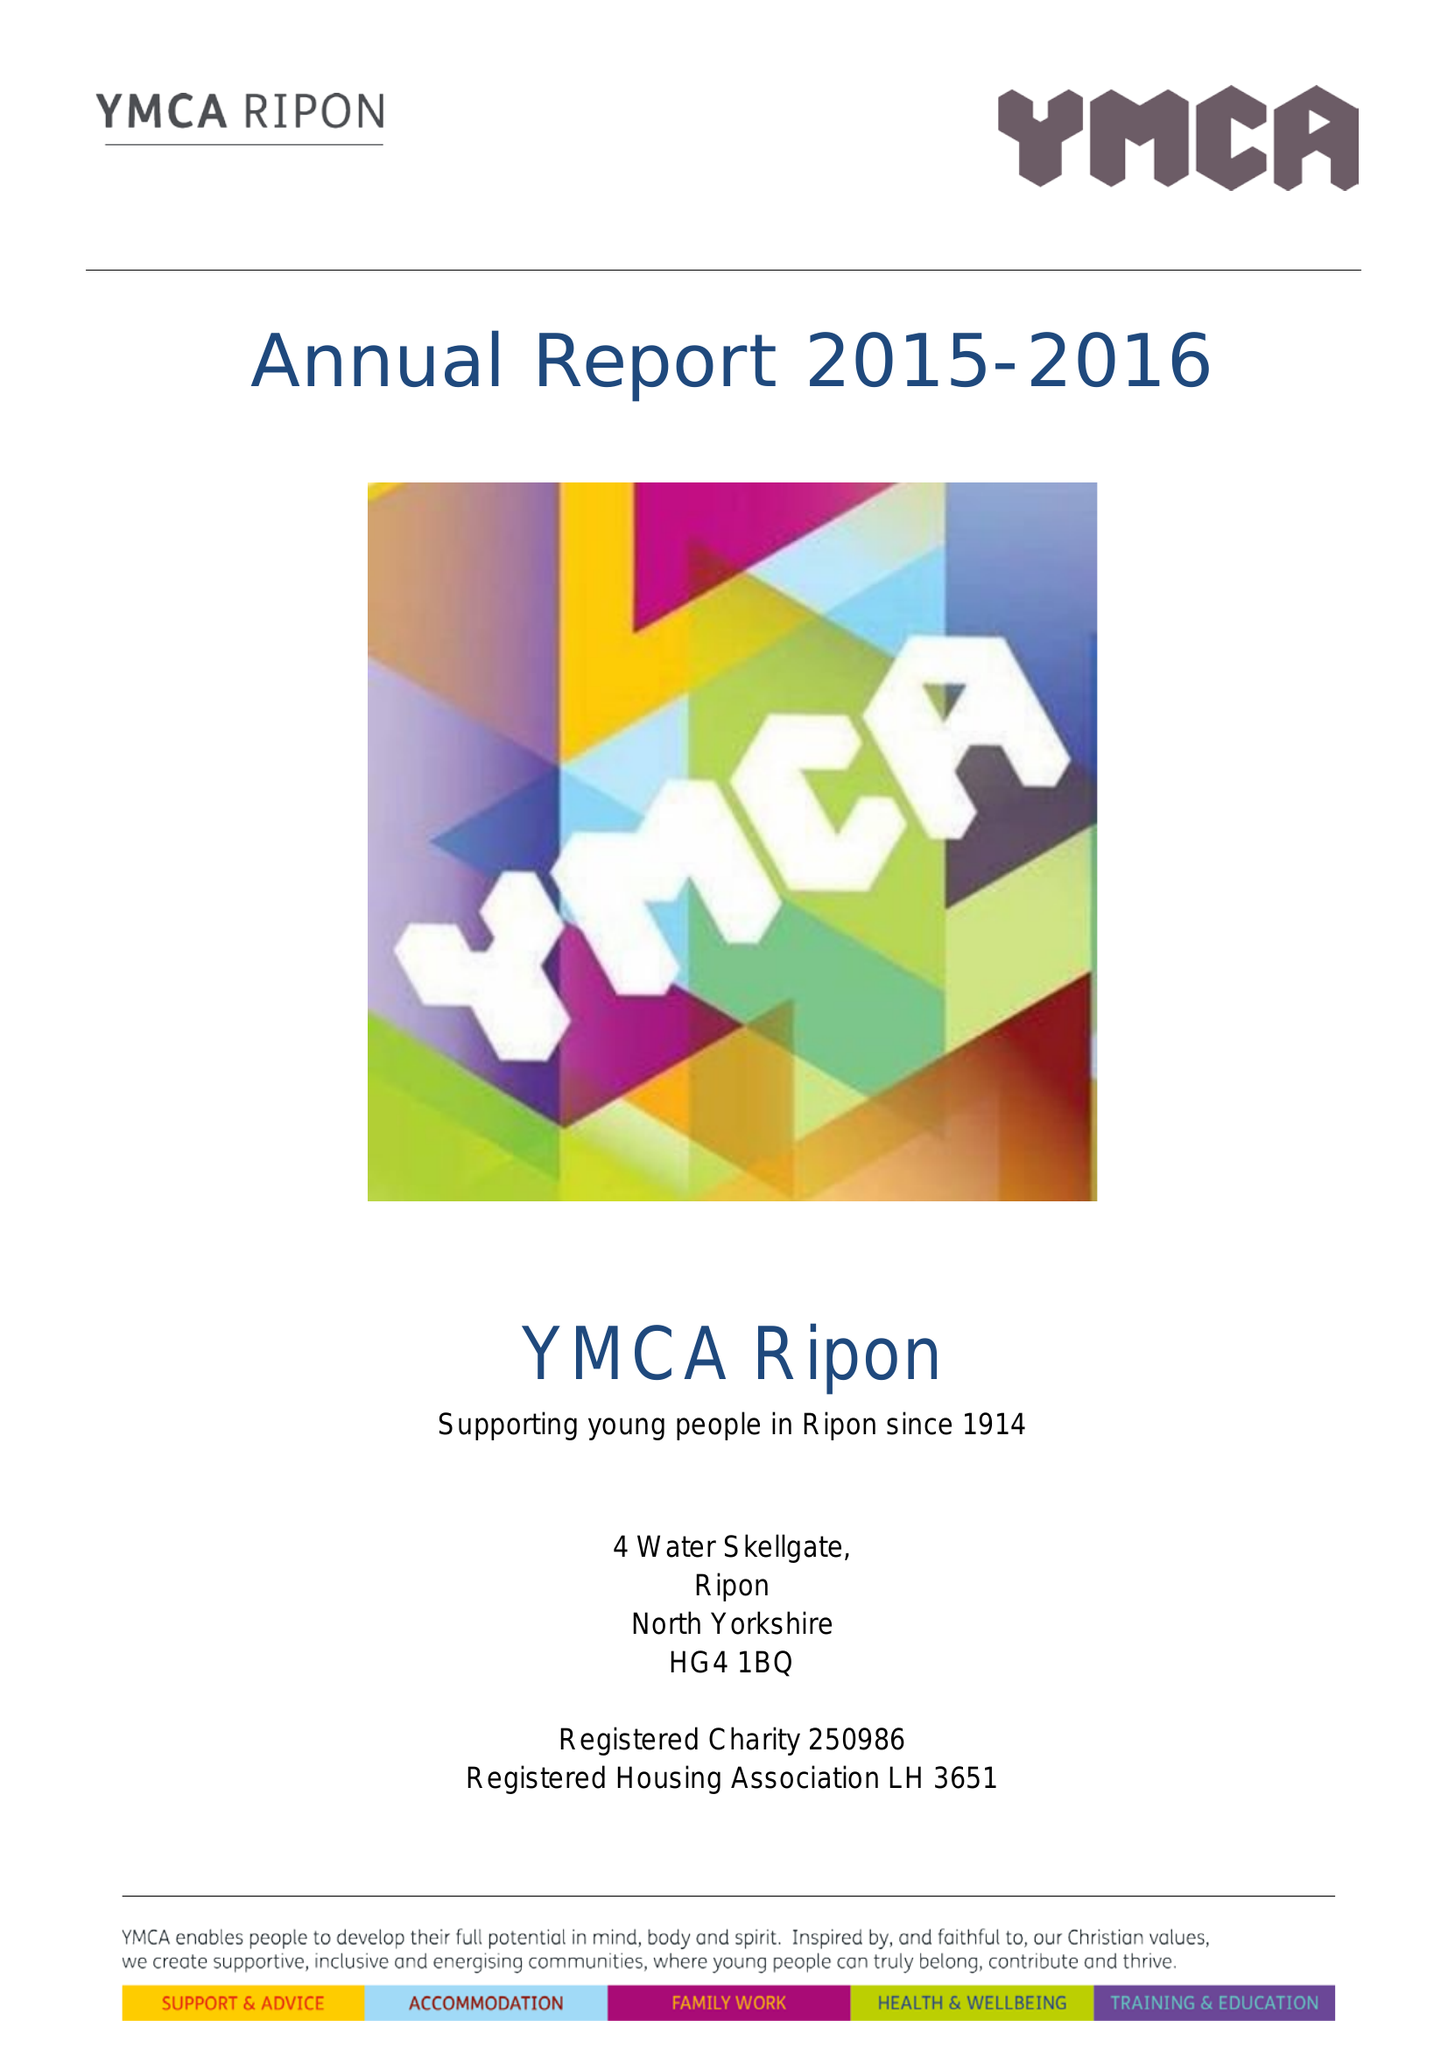What is the value for the report_date?
Answer the question using a single word or phrase. 2016-03-31 